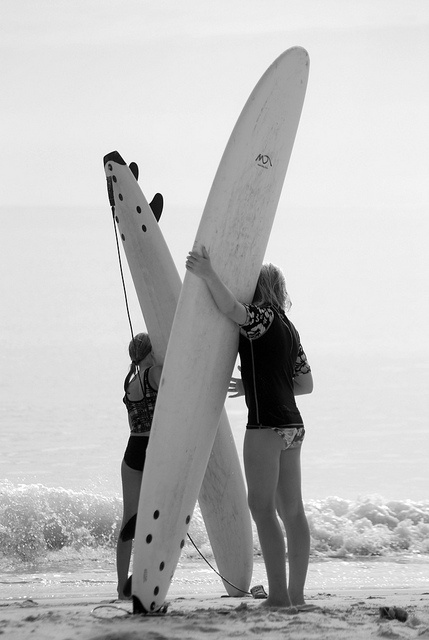Describe the objects in this image and their specific colors. I can see surfboard in lightgray, darkgray, gray, and black tones, people in lightgray, gray, black, and darkgray tones, surfboard in lightgray, gray, and black tones, and people in lightgray, black, gray, and darkgray tones in this image. 